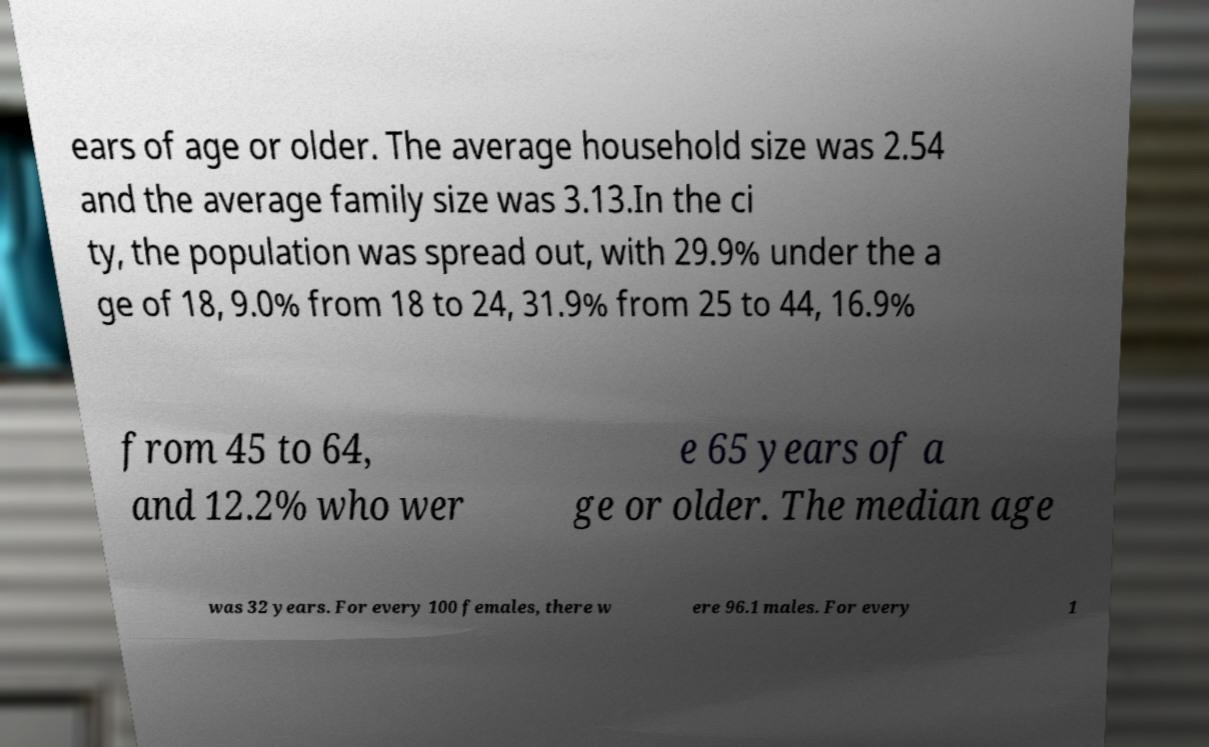Please identify and transcribe the text found in this image. ears of age or older. The average household size was 2.54 and the average family size was 3.13.In the ci ty, the population was spread out, with 29.9% under the a ge of 18, 9.0% from 18 to 24, 31.9% from 25 to 44, 16.9% from 45 to 64, and 12.2% who wer e 65 years of a ge or older. The median age was 32 years. For every 100 females, there w ere 96.1 males. For every 1 